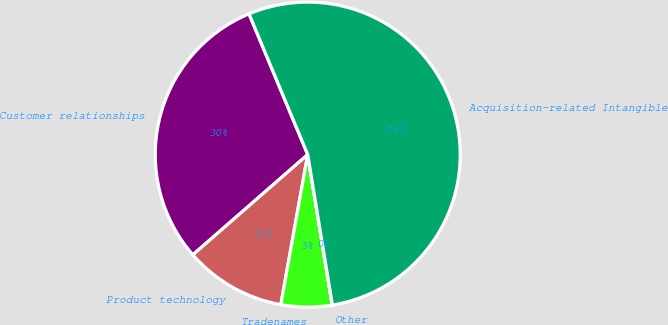Convert chart to OTSL. <chart><loc_0><loc_0><loc_500><loc_500><pie_chart><fcel>Customer relationships<fcel>Product technology<fcel>Tradenames<fcel>Other<fcel>Acquisition-related Intangible<nl><fcel>30.13%<fcel>10.76%<fcel>5.39%<fcel>0.02%<fcel>53.71%<nl></chart> 